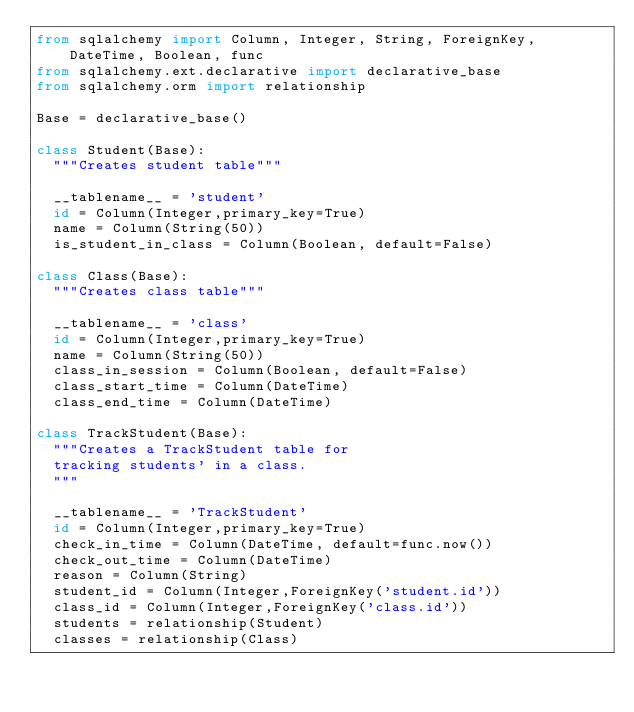Convert code to text. <code><loc_0><loc_0><loc_500><loc_500><_Python_>from sqlalchemy import Column, Integer, String, ForeignKey, DateTime, Boolean, func
from sqlalchemy.ext.declarative import declarative_base
from sqlalchemy.orm import relationship

Base = declarative_base()

class Student(Base):
	"""Creates student table"""

	__tablename__ = 'student'
	id = Column(Integer,primary_key=True)
	name = Column(String(50))
	is_student_in_class = Column(Boolean, default=False)    

class Class(Base):
	"""Creates class table"""

	__tablename__ = 'class'
	id = Column(Integer,primary_key=True)
	name = Column(String(50))
	class_in_session = Column(Boolean, default=False)
	class_start_time = Column(DateTime)
	class_end_time = Column(DateTime)

class TrackStudent(Base):
	"""Creates a TrackStudent table for 
	tracking students' in a class.
	"""

	__tablename__ = 'TrackStudent'
	id = Column(Integer,primary_key=True)
	check_in_time = Column(DateTime, default=func.now())
	check_out_time = Column(DateTime)
	reason = Column(String)
	student_id = Column(Integer,ForeignKey('student.id'))
	class_id = Column(Integer,ForeignKey('class.id'))
	students = relationship(Student)
	classes = relationship(Class)
</code> 